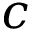Convert formula to latex. <formula><loc_0><loc_0><loc_500><loc_500>c</formula> 